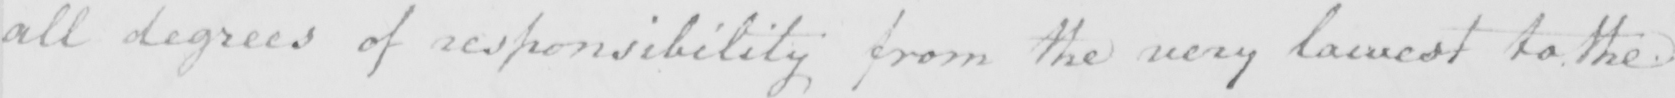Please transcribe the handwritten text in this image. all degrees of responsibility from the very lowest to the 